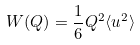Convert formula to latex. <formula><loc_0><loc_0><loc_500><loc_500>W ( Q ) = \frac { 1 } { 6 } Q ^ { 2 } \langle u ^ { 2 } \rangle</formula> 